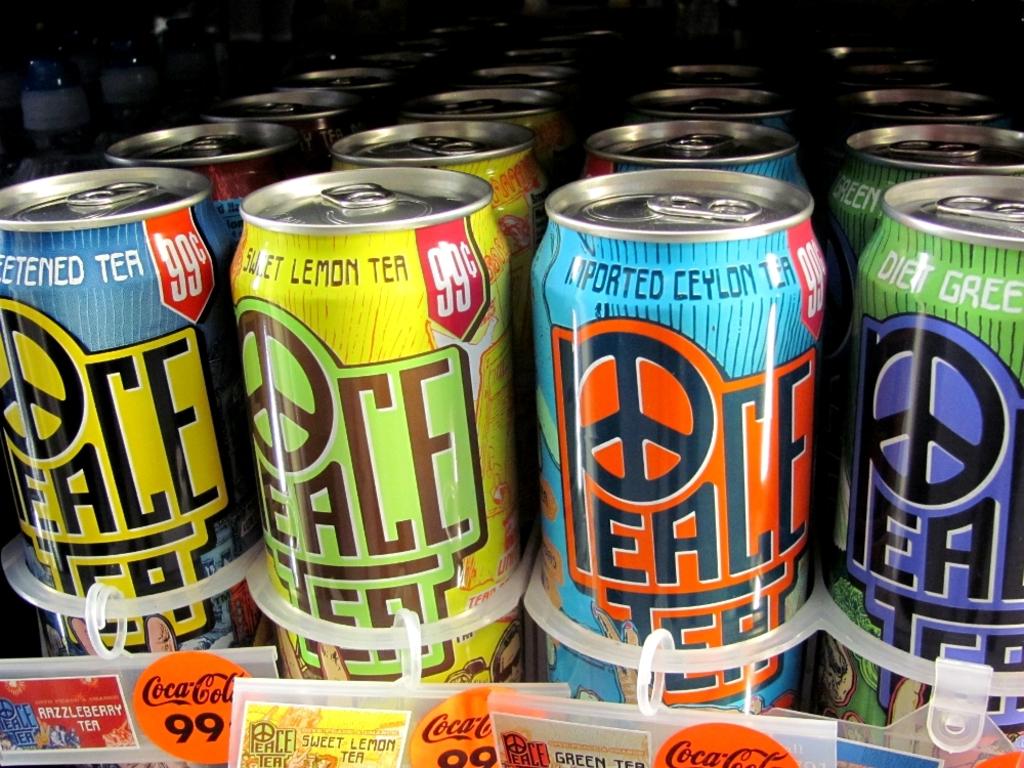Is this tea?
Keep it short and to the point. Yes. What is the flavor of the yellow can?
Give a very brief answer. Sweet lemon tea. 